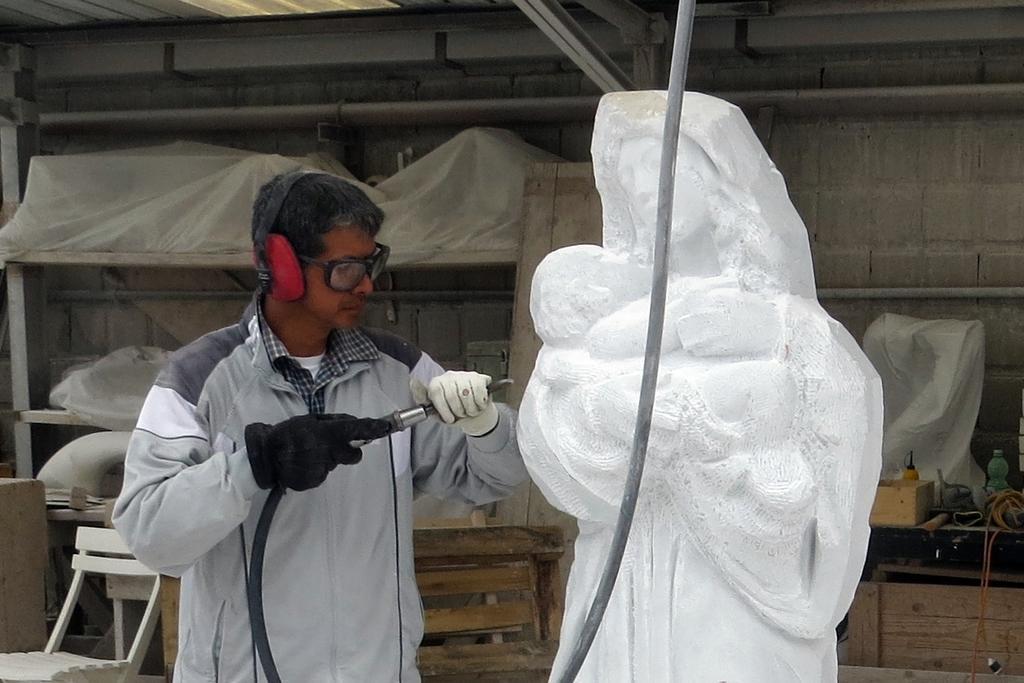In one or two sentences, can you explain what this image depicts? In this image a man is carving a sculpture with a machine in his hand. He wore headsets on head. In the left side of the image there is a chair. In the right side of the image there is a desk. At the background there is a wall and shelves. 